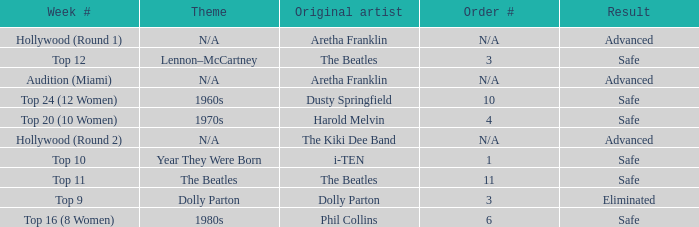What is the week number with Phil Collins as the original artist? Top 16 (8 Women). 